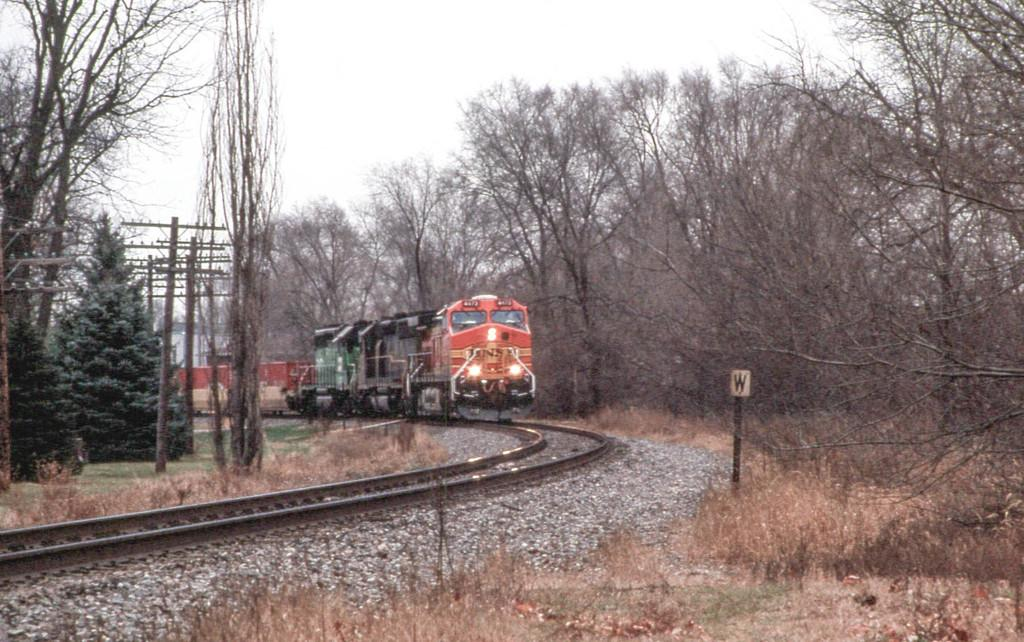What is the main subject of the image? The main subject of the image is a train. Where is the train located in the image? The train is on a railway track. What can be seen in the background of the image? In the background of the image, there are electric poles, trees, sign boards, stones, and the ground. What game is the train playing with its partner in the image? There is no game or partner present in the image; it simply shows a train on a railway track. 